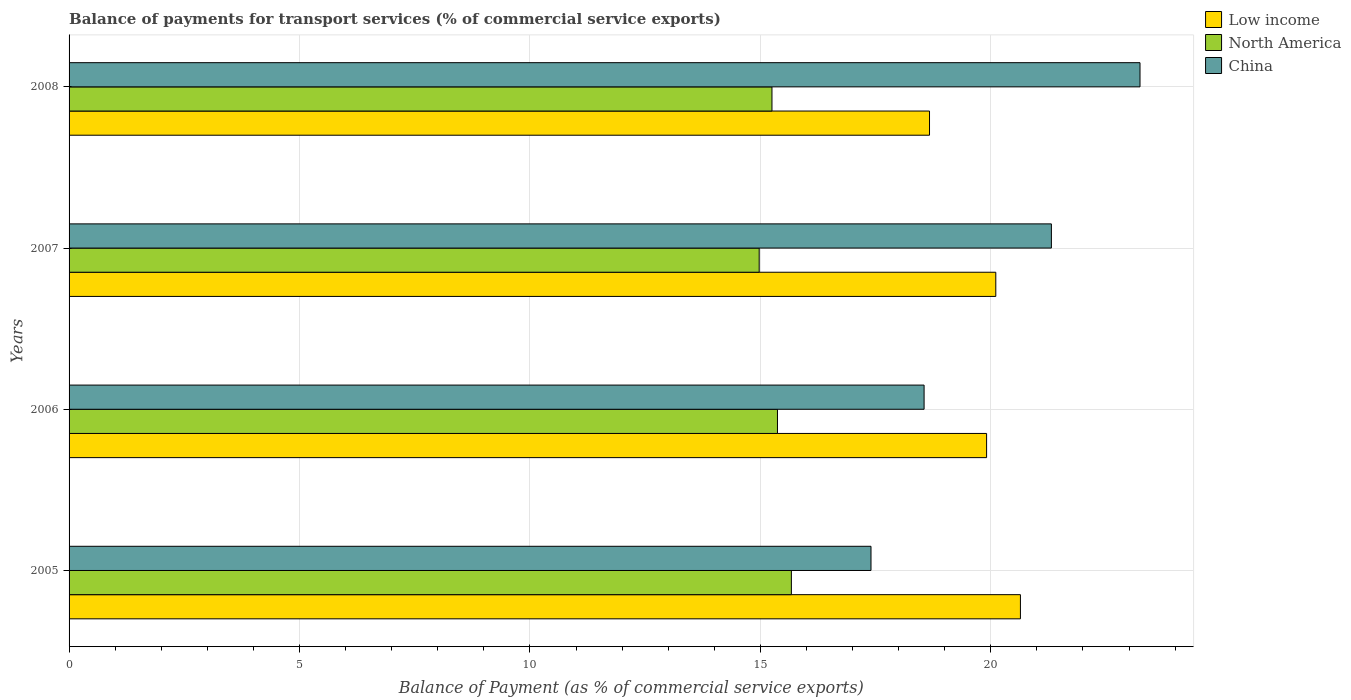How many groups of bars are there?
Offer a very short reply. 4. Are the number of bars per tick equal to the number of legend labels?
Give a very brief answer. Yes. How many bars are there on the 3rd tick from the bottom?
Your response must be concise. 3. In how many cases, is the number of bars for a given year not equal to the number of legend labels?
Offer a terse response. 0. What is the balance of payments for transport services in Low income in 2005?
Give a very brief answer. 20.64. Across all years, what is the maximum balance of payments for transport services in China?
Give a very brief answer. 23.24. Across all years, what is the minimum balance of payments for transport services in North America?
Keep it short and to the point. 14.97. What is the total balance of payments for transport services in China in the graph?
Keep it short and to the point. 80.51. What is the difference between the balance of payments for transport services in China in 2006 and that in 2007?
Provide a short and direct response. -2.76. What is the difference between the balance of payments for transport services in China in 2006 and the balance of payments for transport services in Low income in 2008?
Keep it short and to the point. -0.12. What is the average balance of payments for transport services in Low income per year?
Offer a very short reply. 19.83. In the year 2006, what is the difference between the balance of payments for transport services in China and balance of payments for transport services in Low income?
Ensure brevity in your answer.  -1.36. What is the ratio of the balance of payments for transport services in China in 2005 to that in 2007?
Make the answer very short. 0.82. What is the difference between the highest and the second highest balance of payments for transport services in Low income?
Offer a very short reply. 0.53. What is the difference between the highest and the lowest balance of payments for transport services in Low income?
Offer a very short reply. 1.97. Is it the case that in every year, the sum of the balance of payments for transport services in Low income and balance of payments for transport services in North America is greater than the balance of payments for transport services in China?
Give a very brief answer. Yes. How many bars are there?
Ensure brevity in your answer.  12. Are the values on the major ticks of X-axis written in scientific E-notation?
Offer a terse response. No. Where does the legend appear in the graph?
Your response must be concise. Top right. How are the legend labels stacked?
Provide a succinct answer. Vertical. What is the title of the graph?
Keep it short and to the point. Balance of payments for transport services (% of commercial service exports). Does "Slovenia" appear as one of the legend labels in the graph?
Give a very brief answer. No. What is the label or title of the X-axis?
Give a very brief answer. Balance of Payment (as % of commercial service exports). What is the Balance of Payment (as % of commercial service exports) in Low income in 2005?
Provide a short and direct response. 20.64. What is the Balance of Payment (as % of commercial service exports) in North America in 2005?
Offer a very short reply. 15.67. What is the Balance of Payment (as % of commercial service exports) in China in 2005?
Your answer should be compact. 17.4. What is the Balance of Payment (as % of commercial service exports) of Low income in 2006?
Your response must be concise. 19.91. What is the Balance of Payment (as % of commercial service exports) in North America in 2006?
Provide a succinct answer. 15.37. What is the Balance of Payment (as % of commercial service exports) in China in 2006?
Provide a short and direct response. 18.55. What is the Balance of Payment (as % of commercial service exports) of Low income in 2007?
Give a very brief answer. 20.11. What is the Balance of Payment (as % of commercial service exports) in North America in 2007?
Your response must be concise. 14.97. What is the Balance of Payment (as % of commercial service exports) in China in 2007?
Offer a very short reply. 21.31. What is the Balance of Payment (as % of commercial service exports) of Low income in 2008?
Make the answer very short. 18.67. What is the Balance of Payment (as % of commercial service exports) in North America in 2008?
Make the answer very short. 15.25. What is the Balance of Payment (as % of commercial service exports) in China in 2008?
Offer a very short reply. 23.24. Across all years, what is the maximum Balance of Payment (as % of commercial service exports) in Low income?
Your answer should be compact. 20.64. Across all years, what is the maximum Balance of Payment (as % of commercial service exports) of North America?
Your answer should be very brief. 15.67. Across all years, what is the maximum Balance of Payment (as % of commercial service exports) in China?
Make the answer very short. 23.24. Across all years, what is the minimum Balance of Payment (as % of commercial service exports) in Low income?
Offer a very short reply. 18.67. Across all years, what is the minimum Balance of Payment (as % of commercial service exports) of North America?
Make the answer very short. 14.97. Across all years, what is the minimum Balance of Payment (as % of commercial service exports) of China?
Make the answer very short. 17.4. What is the total Balance of Payment (as % of commercial service exports) of Low income in the graph?
Your answer should be very brief. 79.33. What is the total Balance of Payment (as % of commercial service exports) of North America in the graph?
Provide a succinct answer. 61.27. What is the total Balance of Payment (as % of commercial service exports) in China in the graph?
Provide a succinct answer. 80.51. What is the difference between the Balance of Payment (as % of commercial service exports) of Low income in 2005 and that in 2006?
Your answer should be compact. 0.73. What is the difference between the Balance of Payment (as % of commercial service exports) of North America in 2005 and that in 2006?
Provide a short and direct response. 0.3. What is the difference between the Balance of Payment (as % of commercial service exports) of China in 2005 and that in 2006?
Your answer should be very brief. -1.15. What is the difference between the Balance of Payment (as % of commercial service exports) of Low income in 2005 and that in 2007?
Keep it short and to the point. 0.53. What is the difference between the Balance of Payment (as % of commercial service exports) of North America in 2005 and that in 2007?
Keep it short and to the point. 0.7. What is the difference between the Balance of Payment (as % of commercial service exports) in China in 2005 and that in 2007?
Your response must be concise. -3.91. What is the difference between the Balance of Payment (as % of commercial service exports) in Low income in 2005 and that in 2008?
Keep it short and to the point. 1.97. What is the difference between the Balance of Payment (as % of commercial service exports) of North America in 2005 and that in 2008?
Provide a short and direct response. 0.42. What is the difference between the Balance of Payment (as % of commercial service exports) in China in 2005 and that in 2008?
Offer a very short reply. -5.84. What is the difference between the Balance of Payment (as % of commercial service exports) of Low income in 2006 and that in 2007?
Give a very brief answer. -0.2. What is the difference between the Balance of Payment (as % of commercial service exports) of North America in 2006 and that in 2007?
Keep it short and to the point. 0.4. What is the difference between the Balance of Payment (as % of commercial service exports) in China in 2006 and that in 2007?
Make the answer very short. -2.76. What is the difference between the Balance of Payment (as % of commercial service exports) of Low income in 2006 and that in 2008?
Provide a succinct answer. 1.24. What is the difference between the Balance of Payment (as % of commercial service exports) in North America in 2006 and that in 2008?
Ensure brevity in your answer.  0.12. What is the difference between the Balance of Payment (as % of commercial service exports) of China in 2006 and that in 2008?
Ensure brevity in your answer.  -4.68. What is the difference between the Balance of Payment (as % of commercial service exports) in Low income in 2007 and that in 2008?
Your response must be concise. 1.44. What is the difference between the Balance of Payment (as % of commercial service exports) in North America in 2007 and that in 2008?
Ensure brevity in your answer.  -0.28. What is the difference between the Balance of Payment (as % of commercial service exports) of China in 2007 and that in 2008?
Make the answer very short. -1.92. What is the difference between the Balance of Payment (as % of commercial service exports) of Low income in 2005 and the Balance of Payment (as % of commercial service exports) of North America in 2006?
Your answer should be compact. 5.27. What is the difference between the Balance of Payment (as % of commercial service exports) of Low income in 2005 and the Balance of Payment (as % of commercial service exports) of China in 2006?
Make the answer very short. 2.09. What is the difference between the Balance of Payment (as % of commercial service exports) of North America in 2005 and the Balance of Payment (as % of commercial service exports) of China in 2006?
Offer a very short reply. -2.88. What is the difference between the Balance of Payment (as % of commercial service exports) of Low income in 2005 and the Balance of Payment (as % of commercial service exports) of North America in 2007?
Offer a very short reply. 5.67. What is the difference between the Balance of Payment (as % of commercial service exports) of Low income in 2005 and the Balance of Payment (as % of commercial service exports) of China in 2007?
Offer a terse response. -0.67. What is the difference between the Balance of Payment (as % of commercial service exports) of North America in 2005 and the Balance of Payment (as % of commercial service exports) of China in 2007?
Provide a succinct answer. -5.64. What is the difference between the Balance of Payment (as % of commercial service exports) in Low income in 2005 and the Balance of Payment (as % of commercial service exports) in North America in 2008?
Make the answer very short. 5.39. What is the difference between the Balance of Payment (as % of commercial service exports) in Low income in 2005 and the Balance of Payment (as % of commercial service exports) in China in 2008?
Your response must be concise. -2.59. What is the difference between the Balance of Payment (as % of commercial service exports) in North America in 2005 and the Balance of Payment (as % of commercial service exports) in China in 2008?
Make the answer very short. -7.56. What is the difference between the Balance of Payment (as % of commercial service exports) of Low income in 2006 and the Balance of Payment (as % of commercial service exports) of North America in 2007?
Provide a succinct answer. 4.93. What is the difference between the Balance of Payment (as % of commercial service exports) in Low income in 2006 and the Balance of Payment (as % of commercial service exports) in China in 2007?
Ensure brevity in your answer.  -1.41. What is the difference between the Balance of Payment (as % of commercial service exports) in North America in 2006 and the Balance of Payment (as % of commercial service exports) in China in 2007?
Keep it short and to the point. -5.94. What is the difference between the Balance of Payment (as % of commercial service exports) in Low income in 2006 and the Balance of Payment (as % of commercial service exports) in North America in 2008?
Your answer should be very brief. 4.66. What is the difference between the Balance of Payment (as % of commercial service exports) in Low income in 2006 and the Balance of Payment (as % of commercial service exports) in China in 2008?
Offer a very short reply. -3.33. What is the difference between the Balance of Payment (as % of commercial service exports) of North America in 2006 and the Balance of Payment (as % of commercial service exports) of China in 2008?
Keep it short and to the point. -7.87. What is the difference between the Balance of Payment (as % of commercial service exports) of Low income in 2007 and the Balance of Payment (as % of commercial service exports) of North America in 2008?
Provide a succinct answer. 4.86. What is the difference between the Balance of Payment (as % of commercial service exports) of Low income in 2007 and the Balance of Payment (as % of commercial service exports) of China in 2008?
Keep it short and to the point. -3.13. What is the difference between the Balance of Payment (as % of commercial service exports) of North America in 2007 and the Balance of Payment (as % of commercial service exports) of China in 2008?
Your answer should be compact. -8.26. What is the average Balance of Payment (as % of commercial service exports) in Low income per year?
Your answer should be very brief. 19.83. What is the average Balance of Payment (as % of commercial service exports) in North America per year?
Offer a very short reply. 15.32. What is the average Balance of Payment (as % of commercial service exports) in China per year?
Offer a terse response. 20.13. In the year 2005, what is the difference between the Balance of Payment (as % of commercial service exports) in Low income and Balance of Payment (as % of commercial service exports) in North America?
Keep it short and to the point. 4.97. In the year 2005, what is the difference between the Balance of Payment (as % of commercial service exports) of Low income and Balance of Payment (as % of commercial service exports) of China?
Your answer should be compact. 3.24. In the year 2005, what is the difference between the Balance of Payment (as % of commercial service exports) in North America and Balance of Payment (as % of commercial service exports) in China?
Your response must be concise. -1.73. In the year 2006, what is the difference between the Balance of Payment (as % of commercial service exports) in Low income and Balance of Payment (as % of commercial service exports) in North America?
Offer a terse response. 4.54. In the year 2006, what is the difference between the Balance of Payment (as % of commercial service exports) in Low income and Balance of Payment (as % of commercial service exports) in China?
Keep it short and to the point. 1.36. In the year 2006, what is the difference between the Balance of Payment (as % of commercial service exports) of North America and Balance of Payment (as % of commercial service exports) of China?
Ensure brevity in your answer.  -3.18. In the year 2007, what is the difference between the Balance of Payment (as % of commercial service exports) in Low income and Balance of Payment (as % of commercial service exports) in North America?
Your answer should be compact. 5.13. In the year 2007, what is the difference between the Balance of Payment (as % of commercial service exports) in Low income and Balance of Payment (as % of commercial service exports) in China?
Provide a succinct answer. -1.21. In the year 2007, what is the difference between the Balance of Payment (as % of commercial service exports) of North America and Balance of Payment (as % of commercial service exports) of China?
Your answer should be compact. -6.34. In the year 2008, what is the difference between the Balance of Payment (as % of commercial service exports) in Low income and Balance of Payment (as % of commercial service exports) in North America?
Offer a very short reply. 3.42. In the year 2008, what is the difference between the Balance of Payment (as % of commercial service exports) in Low income and Balance of Payment (as % of commercial service exports) in China?
Provide a succinct answer. -4.57. In the year 2008, what is the difference between the Balance of Payment (as % of commercial service exports) of North America and Balance of Payment (as % of commercial service exports) of China?
Ensure brevity in your answer.  -7.99. What is the ratio of the Balance of Payment (as % of commercial service exports) of Low income in 2005 to that in 2006?
Offer a terse response. 1.04. What is the ratio of the Balance of Payment (as % of commercial service exports) of North America in 2005 to that in 2006?
Offer a terse response. 1.02. What is the ratio of the Balance of Payment (as % of commercial service exports) in China in 2005 to that in 2006?
Make the answer very short. 0.94. What is the ratio of the Balance of Payment (as % of commercial service exports) of Low income in 2005 to that in 2007?
Your answer should be compact. 1.03. What is the ratio of the Balance of Payment (as % of commercial service exports) in North America in 2005 to that in 2007?
Make the answer very short. 1.05. What is the ratio of the Balance of Payment (as % of commercial service exports) in China in 2005 to that in 2007?
Ensure brevity in your answer.  0.82. What is the ratio of the Balance of Payment (as % of commercial service exports) in Low income in 2005 to that in 2008?
Your answer should be compact. 1.11. What is the ratio of the Balance of Payment (as % of commercial service exports) of North America in 2005 to that in 2008?
Give a very brief answer. 1.03. What is the ratio of the Balance of Payment (as % of commercial service exports) of China in 2005 to that in 2008?
Your response must be concise. 0.75. What is the ratio of the Balance of Payment (as % of commercial service exports) of Low income in 2006 to that in 2007?
Offer a very short reply. 0.99. What is the ratio of the Balance of Payment (as % of commercial service exports) in North America in 2006 to that in 2007?
Ensure brevity in your answer.  1.03. What is the ratio of the Balance of Payment (as % of commercial service exports) in China in 2006 to that in 2007?
Your answer should be very brief. 0.87. What is the ratio of the Balance of Payment (as % of commercial service exports) of Low income in 2006 to that in 2008?
Your answer should be compact. 1.07. What is the ratio of the Balance of Payment (as % of commercial service exports) in China in 2006 to that in 2008?
Give a very brief answer. 0.8. What is the ratio of the Balance of Payment (as % of commercial service exports) of Low income in 2007 to that in 2008?
Provide a succinct answer. 1.08. What is the ratio of the Balance of Payment (as % of commercial service exports) of North America in 2007 to that in 2008?
Give a very brief answer. 0.98. What is the ratio of the Balance of Payment (as % of commercial service exports) in China in 2007 to that in 2008?
Your answer should be very brief. 0.92. What is the difference between the highest and the second highest Balance of Payment (as % of commercial service exports) of Low income?
Provide a succinct answer. 0.53. What is the difference between the highest and the second highest Balance of Payment (as % of commercial service exports) of North America?
Ensure brevity in your answer.  0.3. What is the difference between the highest and the second highest Balance of Payment (as % of commercial service exports) in China?
Offer a very short reply. 1.92. What is the difference between the highest and the lowest Balance of Payment (as % of commercial service exports) of Low income?
Ensure brevity in your answer.  1.97. What is the difference between the highest and the lowest Balance of Payment (as % of commercial service exports) in North America?
Provide a succinct answer. 0.7. What is the difference between the highest and the lowest Balance of Payment (as % of commercial service exports) in China?
Offer a very short reply. 5.84. 